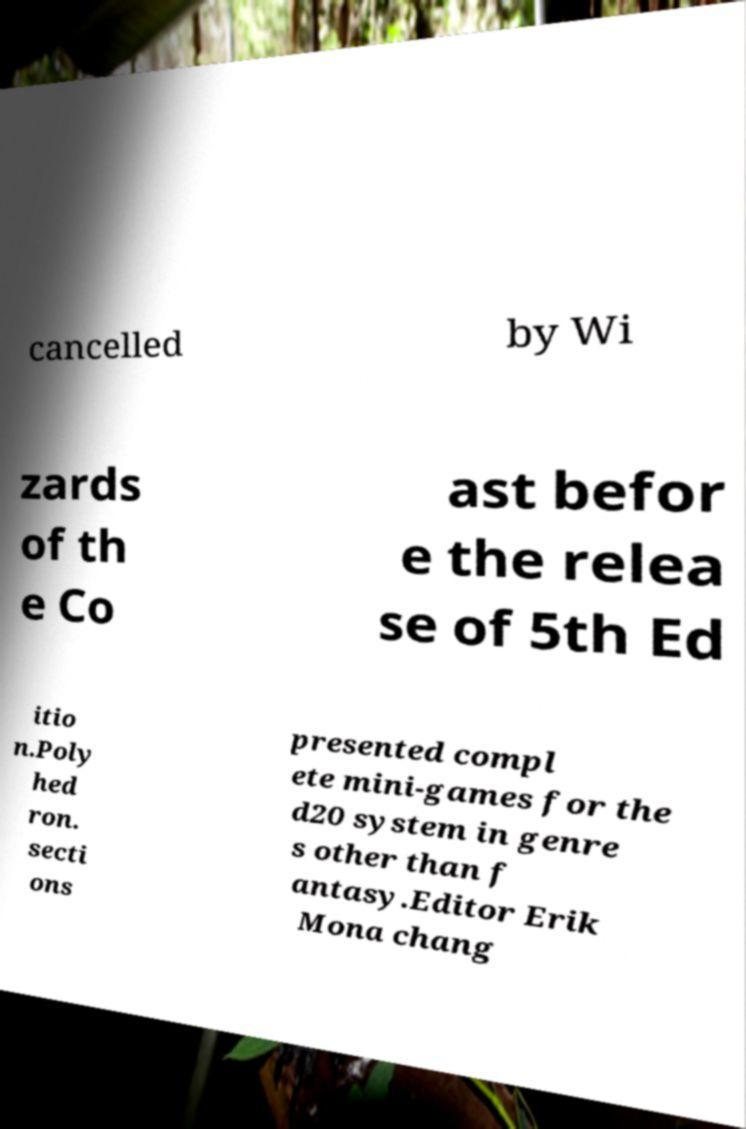Could you extract and type out the text from this image? cancelled by Wi zards of th e Co ast befor e the relea se of 5th Ed itio n.Poly hed ron. secti ons presented compl ete mini-games for the d20 system in genre s other than f antasy.Editor Erik Mona chang 